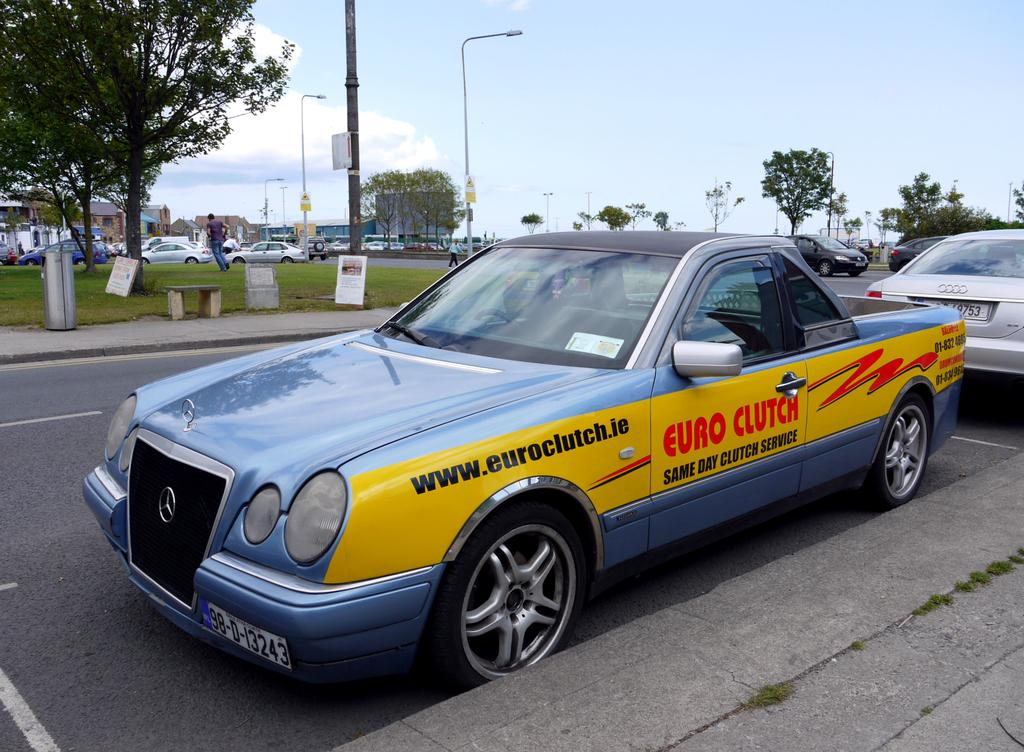<image>
Summarize the visual content of the image. Euro Clutch is using a Mercedes to advertise it's clutch services. 